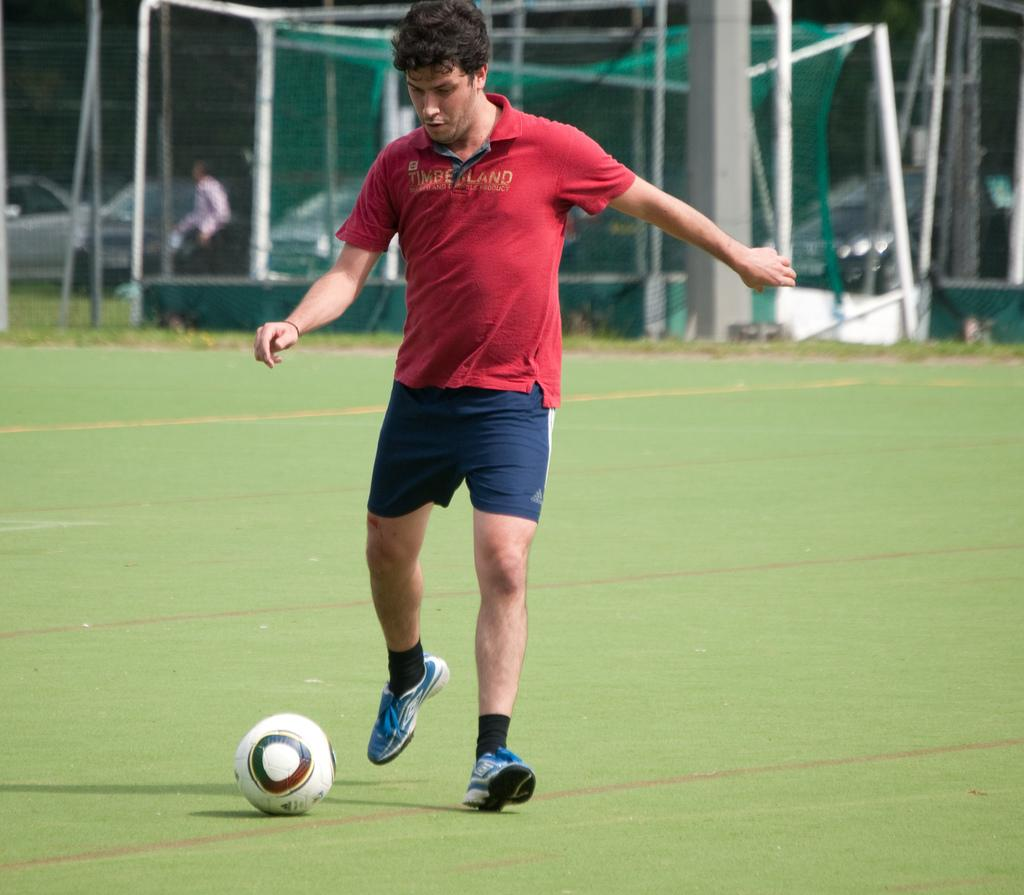What is the main action of the person in the image? There is a person walking in the image. Can you describe the position of the second person in the image? There is another person at the back. What type of vehicles can be seen in the image? There are cars visible in the image. What is the barrier between the people and the cars in the image? There is a fence in the image. What type of ground is visible at the bottom of the image? There is grass at the bottom of the image. What object can be seen near the person walking in the image? There is a ball in the image. What type of poison is being used by the government in the image? There is no mention of poison or the government in the image; it features a person walking and a ball. Can you describe the lamp that is hanging from the fence in the image? There is no lamp present in the image; it only features a fence, grass, and a ball. 